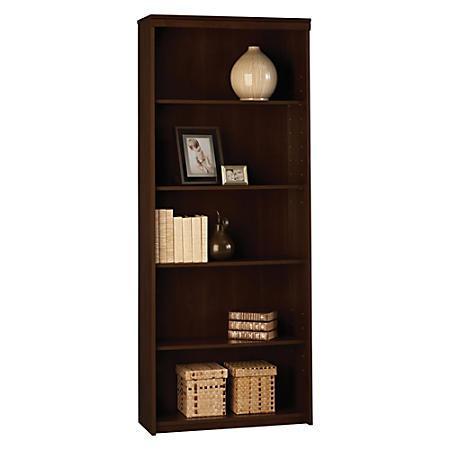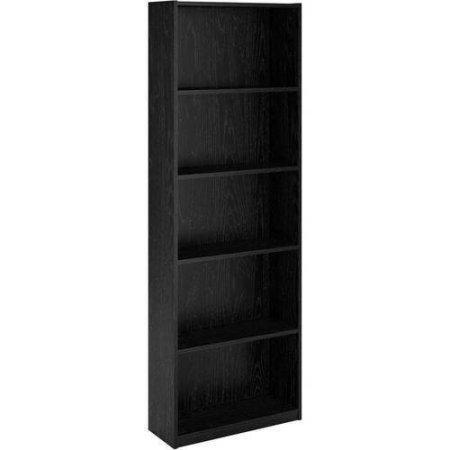The first image is the image on the left, the second image is the image on the right. Analyze the images presented: Is the assertion "One of the bookshelves is white." valid? Answer yes or no. No. 